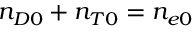<formula> <loc_0><loc_0><loc_500><loc_500>n _ { D 0 } + n _ { T 0 } = n _ { e 0 }</formula> 